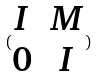Convert formula to latex. <formula><loc_0><loc_0><loc_500><loc_500>( \begin{matrix} I & M \\ 0 & I \end{matrix} )</formula> 